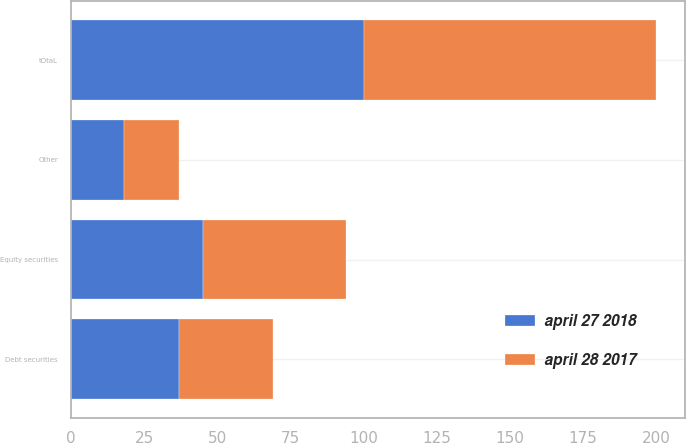<chart> <loc_0><loc_0><loc_500><loc_500><stacked_bar_chart><ecel><fcel>Equity securities<fcel>Debt securities<fcel>Other<fcel>tOtaL<nl><fcel>april 28 2017<fcel>49<fcel>32<fcel>19<fcel>100<nl><fcel>april 27 2018<fcel>45<fcel>37<fcel>18<fcel>100<nl></chart> 